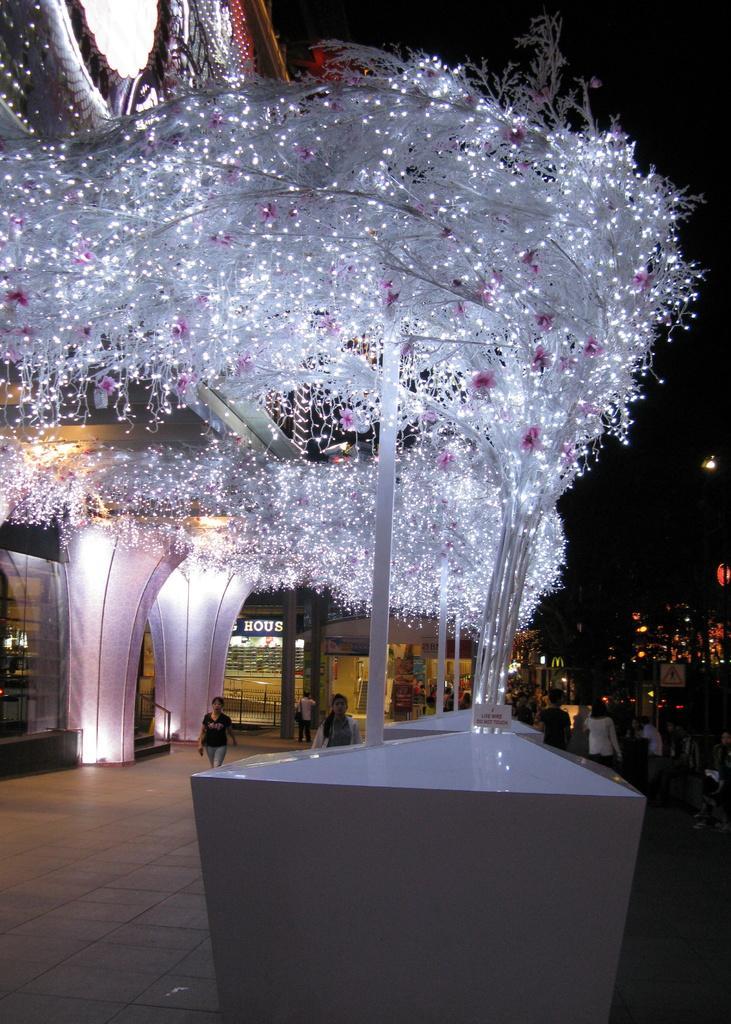Please provide a concise description of this image. In this image we can see tree is decorated with white color lights. There is a shop in the background and people are moving on the pavement. We can see one building on the left side of the image. 